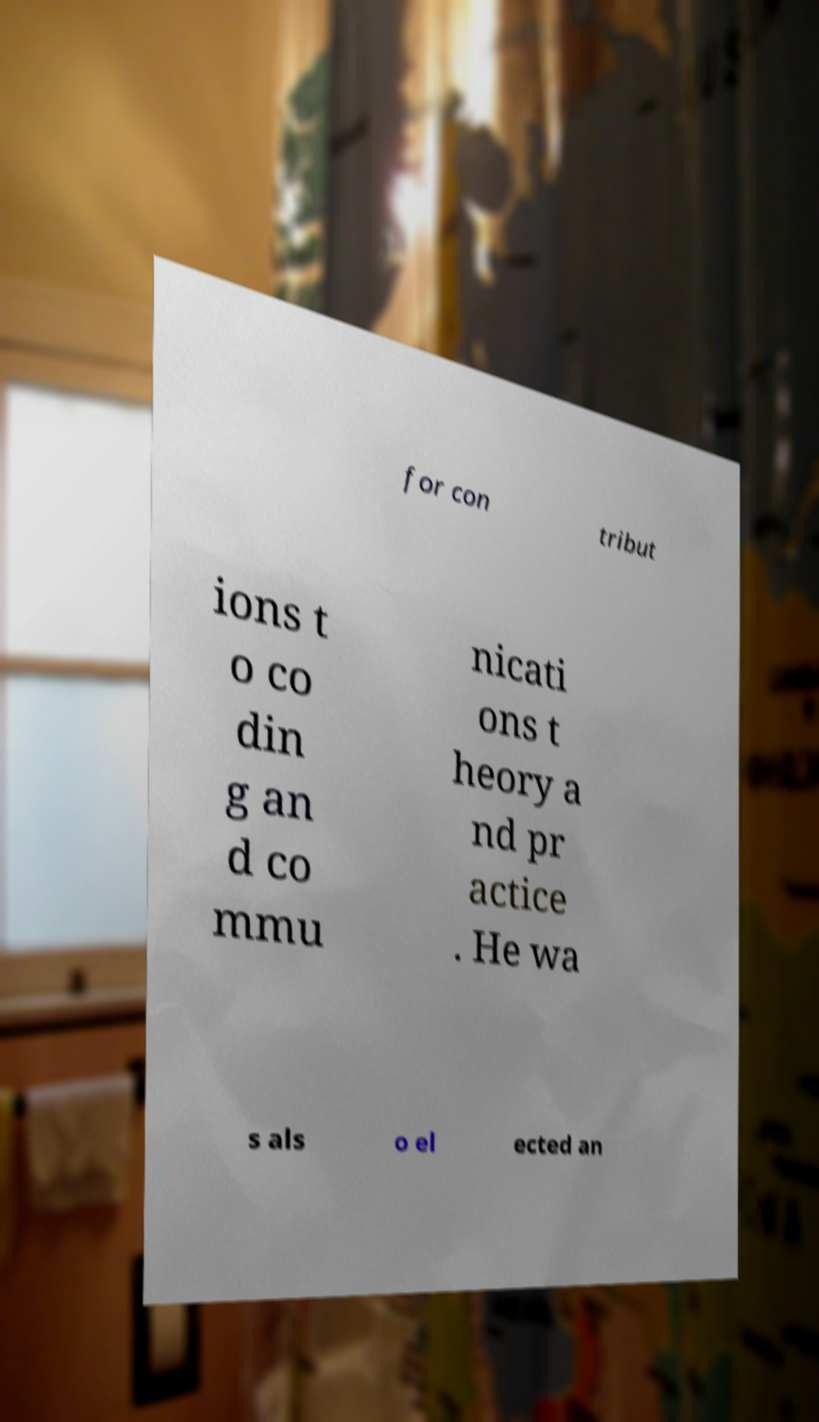Please identify and transcribe the text found in this image. for con tribut ions t o co din g an d co mmu nicati ons t heory a nd pr actice . He wa s als o el ected an 